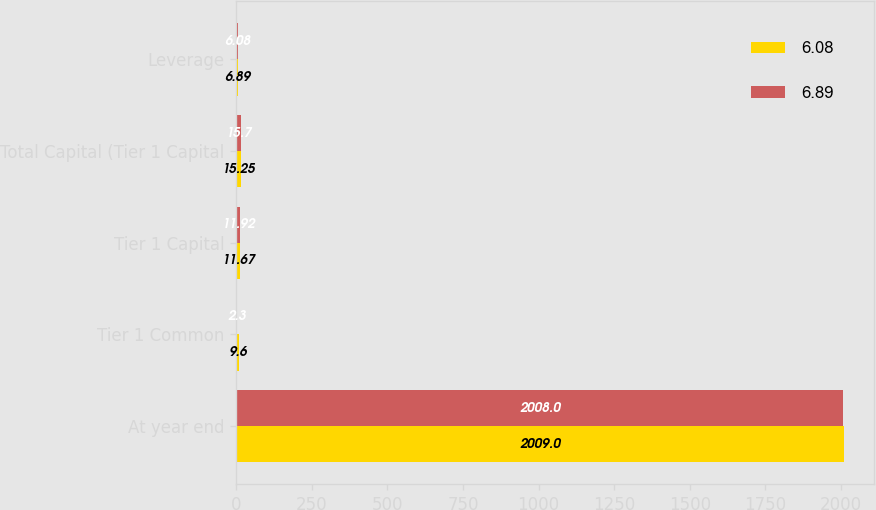Convert chart. <chart><loc_0><loc_0><loc_500><loc_500><stacked_bar_chart><ecel><fcel>At year end<fcel>Tier 1 Common<fcel>Tier 1 Capital<fcel>Total Capital (Tier 1 Capital<fcel>Leverage<nl><fcel>6.08<fcel>2009<fcel>9.6<fcel>11.67<fcel>15.25<fcel>6.89<nl><fcel>6.89<fcel>2008<fcel>2.3<fcel>11.92<fcel>15.7<fcel>6.08<nl></chart> 